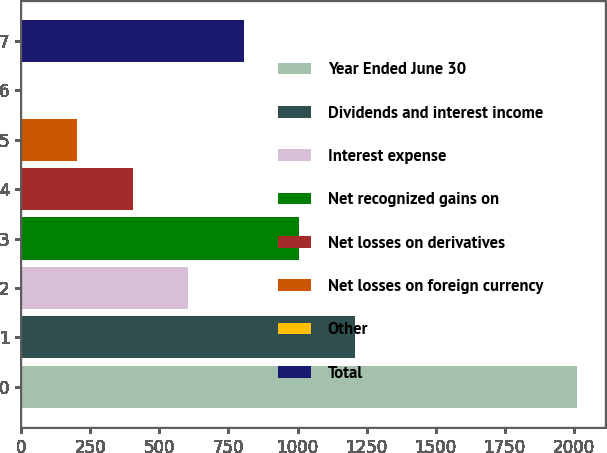<chart> <loc_0><loc_0><loc_500><loc_500><bar_chart><fcel>Year Ended June 30<fcel>Dividends and interest income<fcel>Interest expense<fcel>Net recognized gains on<fcel>Net losses on derivatives<fcel>Net losses on foreign currency<fcel>Other<fcel>Total<nl><fcel>2012<fcel>1207.6<fcel>604.3<fcel>1006.5<fcel>403.2<fcel>202.1<fcel>1<fcel>805.4<nl></chart> 